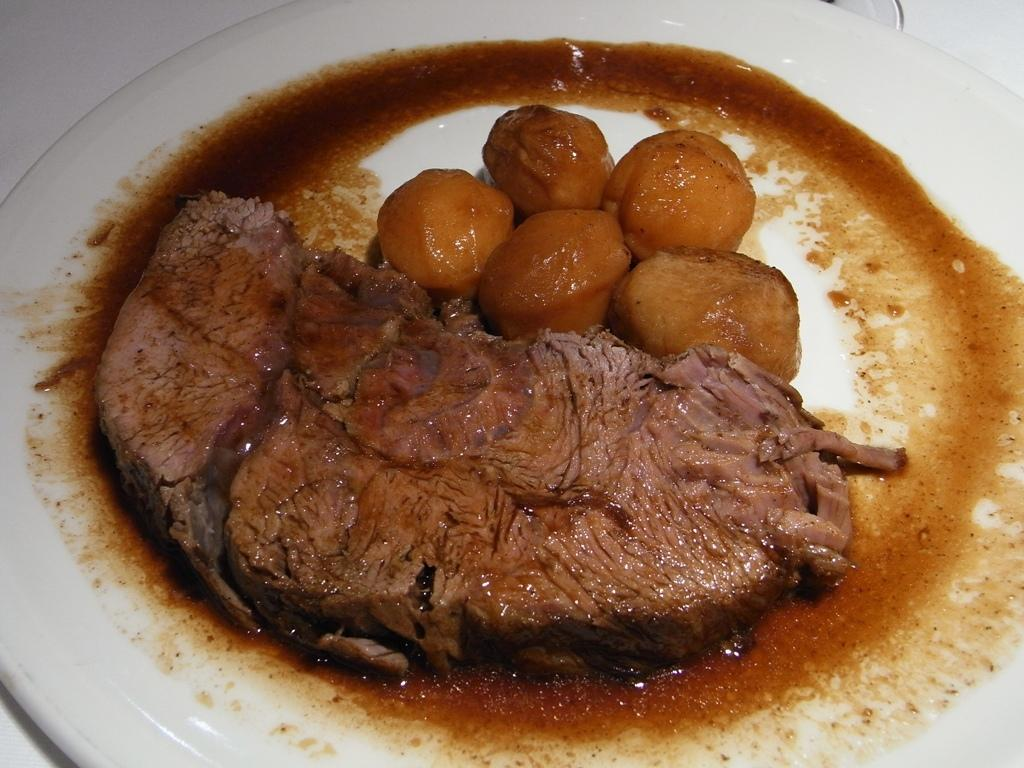What is on the plate that is visible in the image? There is food on a white plate in the image. What type of knee injury can be seen in the image? There is no knee injury present in the image; it only features food on a white plate. 